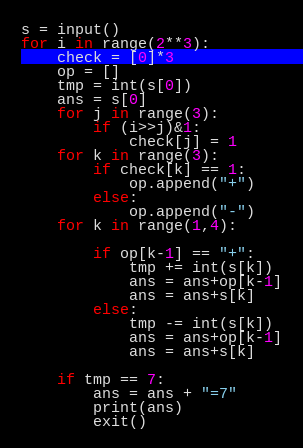Convert code to text. <code><loc_0><loc_0><loc_500><loc_500><_Python_>s = input()
for i in range(2**3):
    check = [0]*3
    op = []
    tmp = int(s[0])
    ans = s[0]
    for j in range(3):
        if (i>>j)&1:
            check[j] = 1
    for k in range(3):
        if check[k] == 1:
            op.append("+")
        else:
            op.append("-")
    for k in range(1,4):

        if op[k-1] == "+":
            tmp += int(s[k])
            ans = ans+op[k-1]
            ans = ans+s[k]
        else:
            tmp -= int(s[k])
            ans = ans+op[k-1]
            ans = ans+s[k]

    if tmp == 7:
        ans = ans + "=7"
        print(ans)
        exit()</code> 